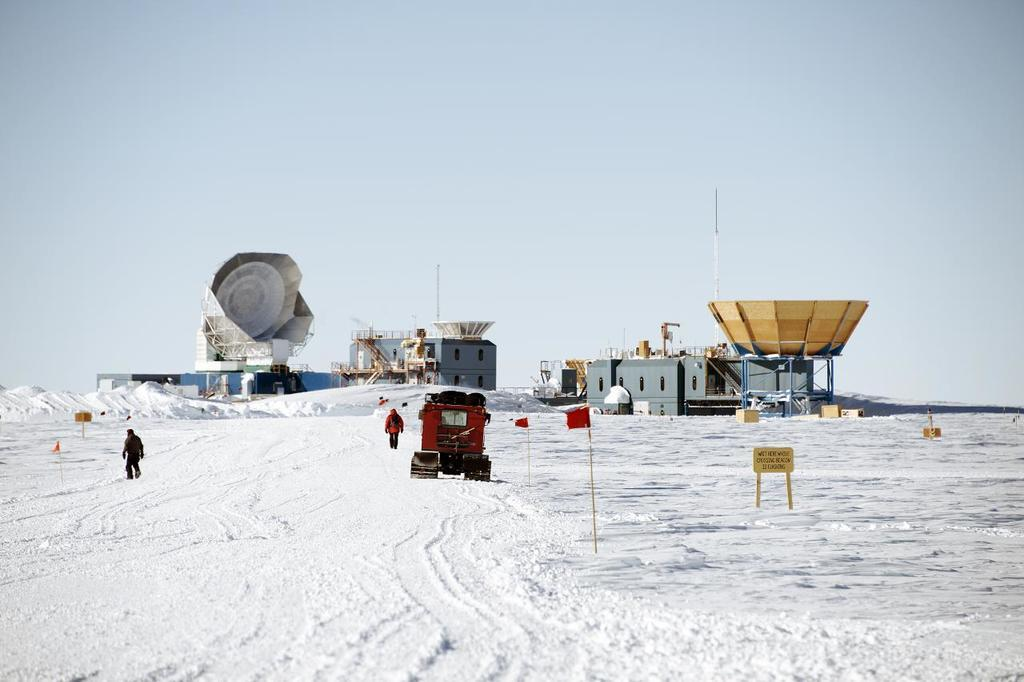What is one of the main elements in the image? There is water in the image. What type of object can be seen in the image? There is a vehicle in the image. What is the symbolic object in the image? There is a flag in the image. What are the two persons in the image doing? Two persons are walking in the image. What part of the natural environment is visible in the image? The sky is visible at the top of the image. What type of structures are present in the image? There are buildings in the image. What architectural feature can be seen in the image? There are stairs in the image. What openings are present in the buildings in the image? There are windows in the image. What type of powder can be seen falling from the sky in the image? There is no powder falling from the sky in the image. What type of knife is being used by the persons in the image? There are no knives present in the image; the persons are walking. 